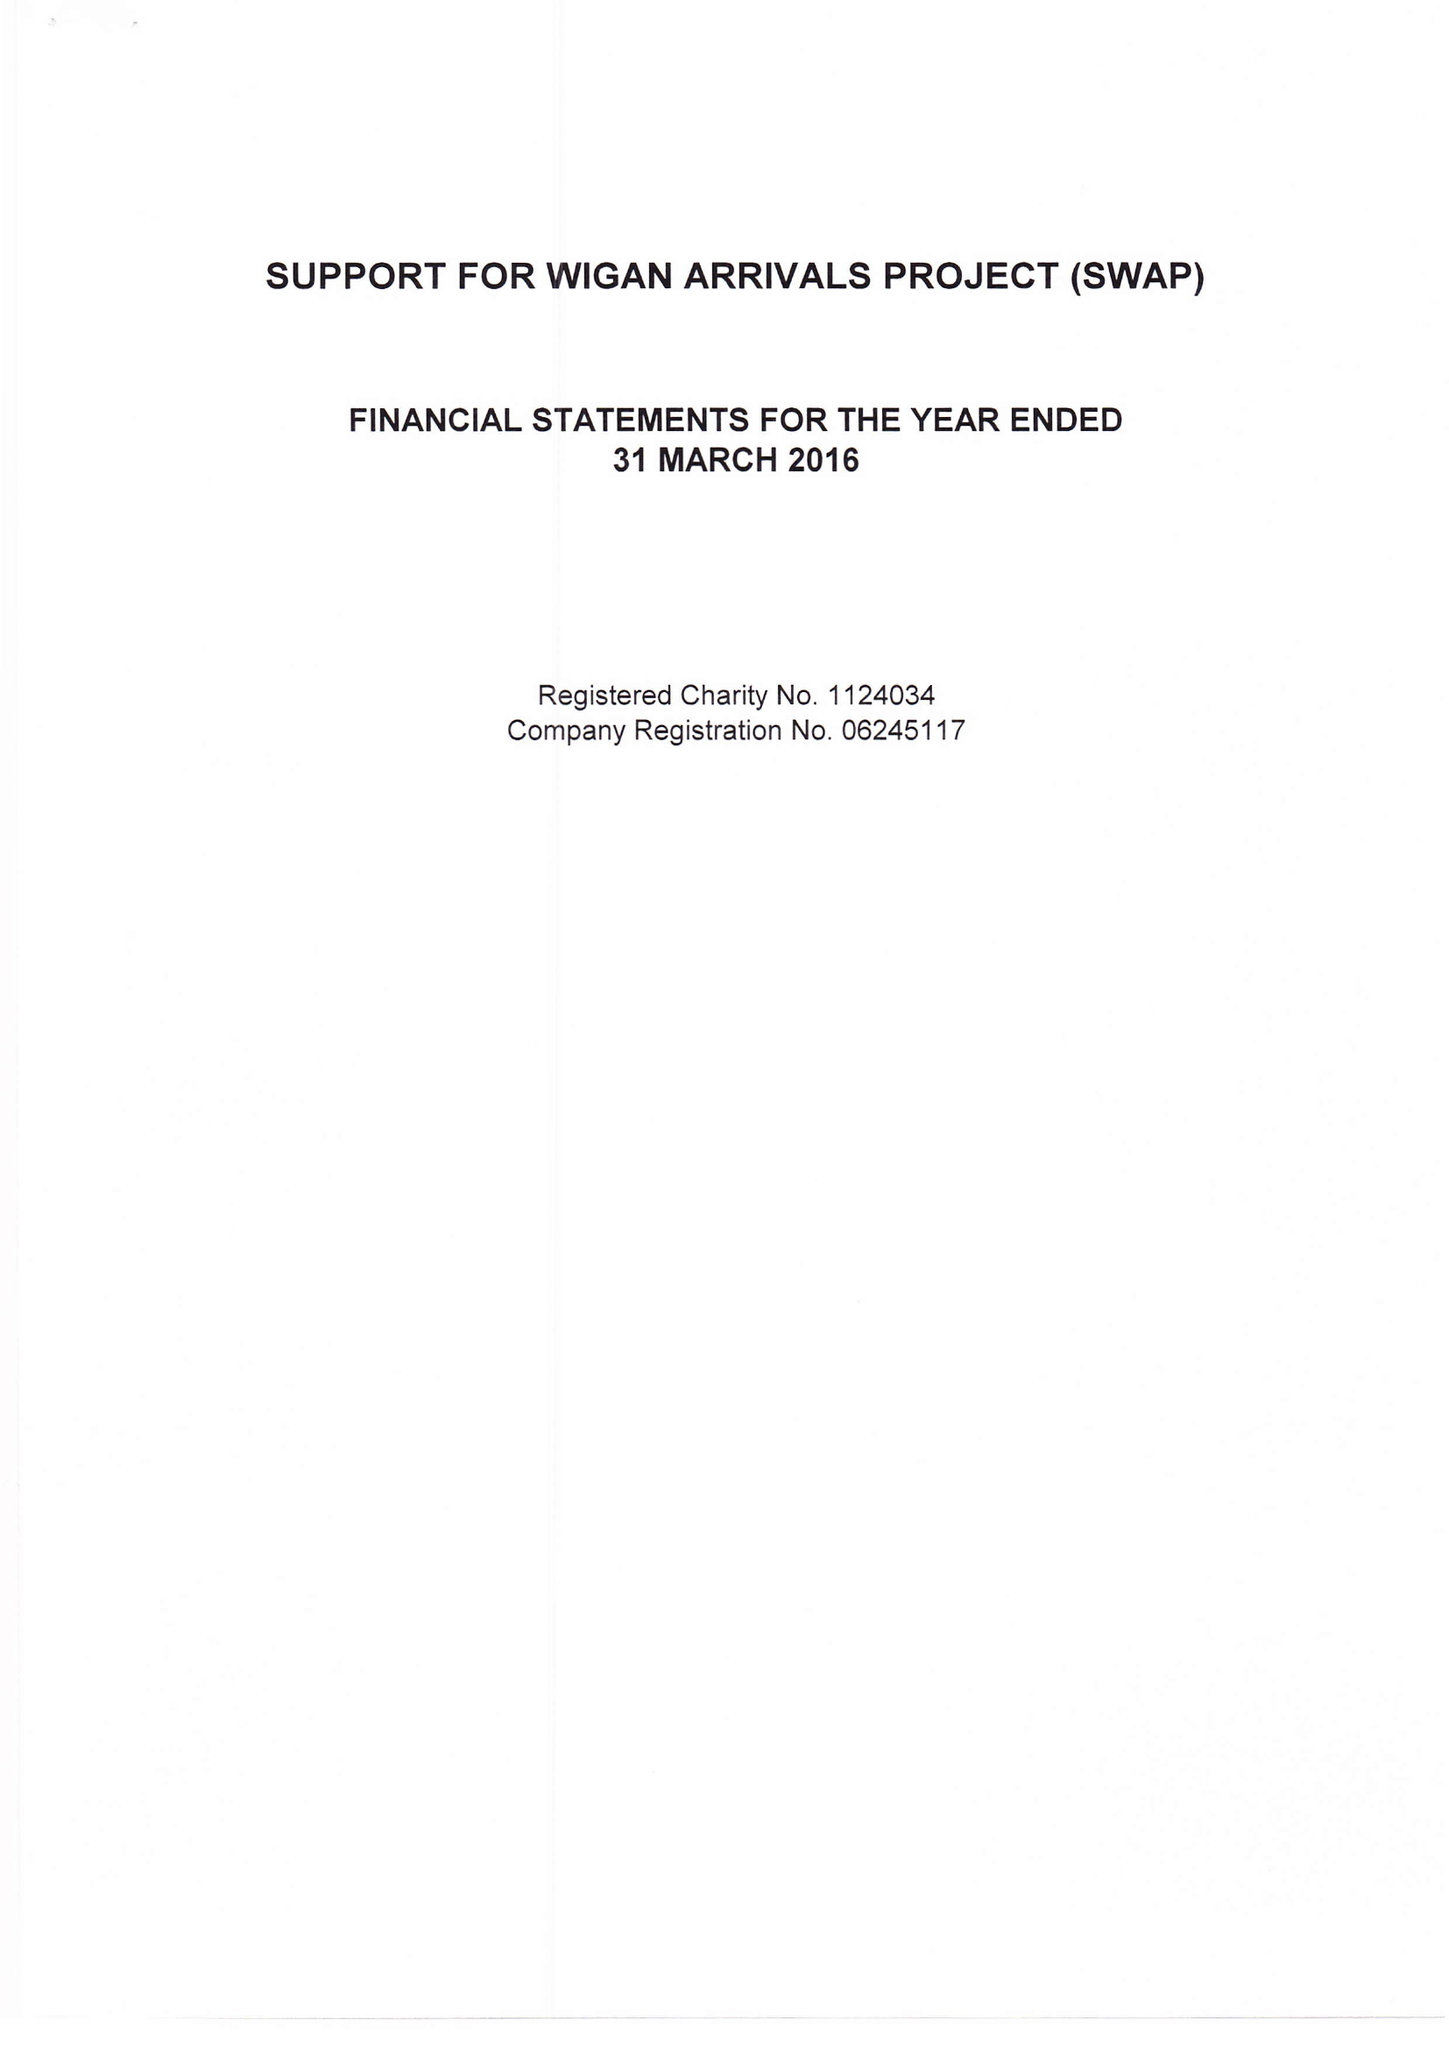What is the value for the spending_annually_in_british_pounds?
Answer the question using a single word or phrase. 67119.00 